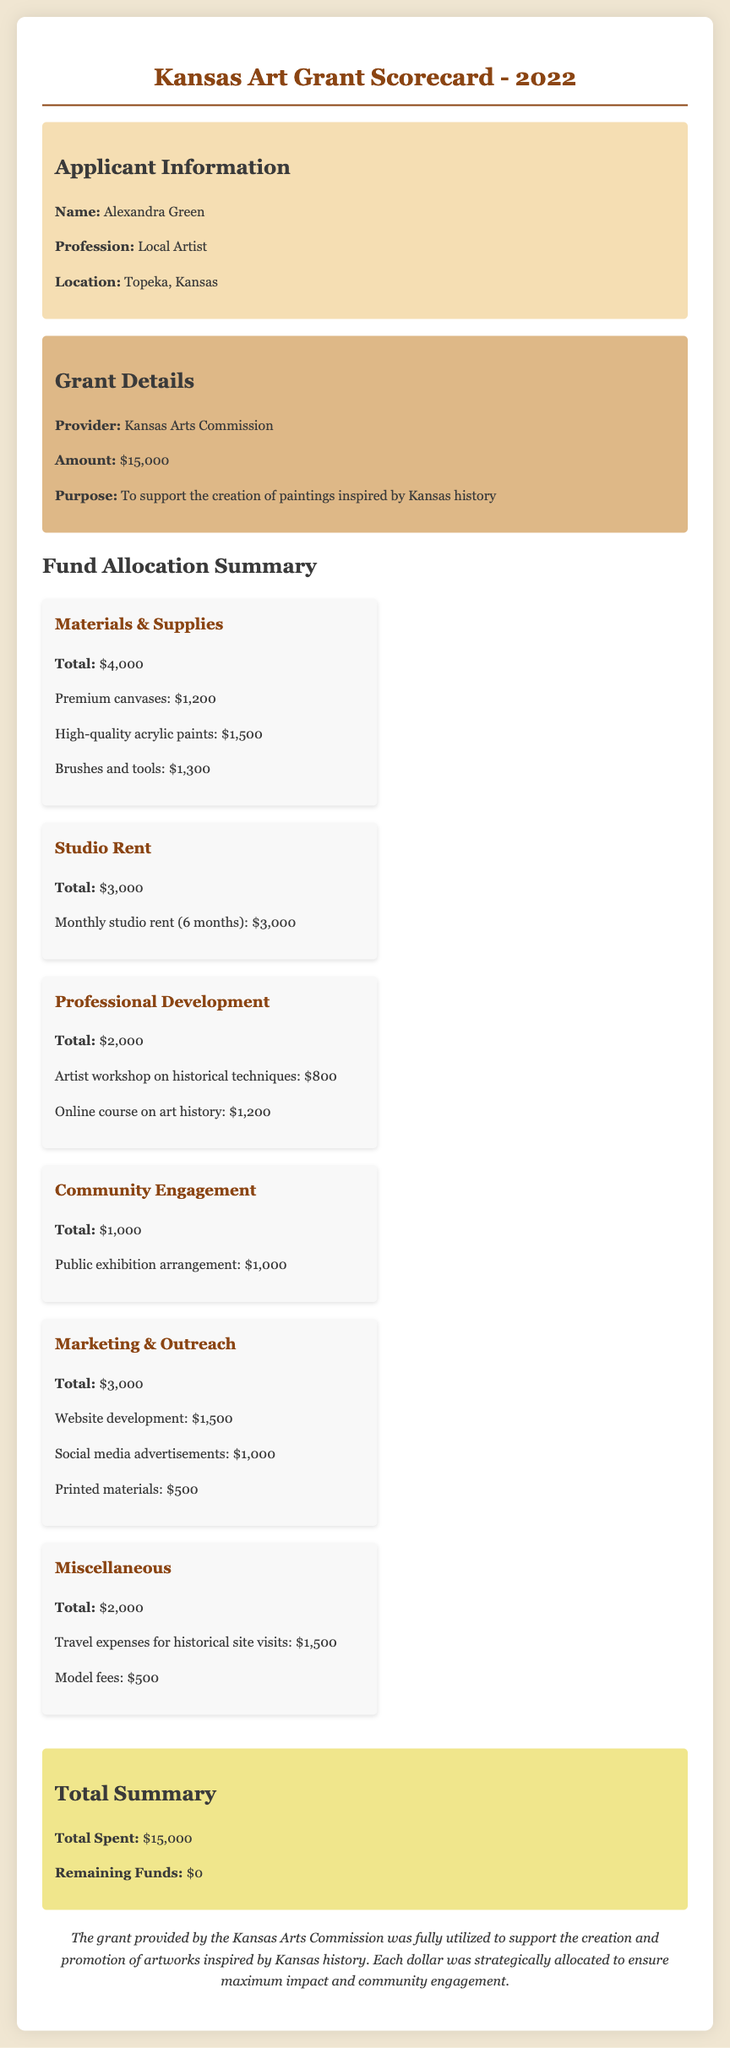what is the name of the applicant? The applicant's name is provided in the document as information related to the applicant.
Answer: Alexandra Green how much was the total grant amount? The total grant amount is stated in the grant details section of the document.
Answer: $15,000 what was the total amount allocated for materials and supplies? The allocation for materials and supplies is listed under the Fund Allocation Summary section.
Answer: $4,000 how much was spent on community engagement? The amount spent on community engagement can be found under the relevant category in the Fund Allocation Summary.
Answer: $1,000 what is the purpose of the grant? The purpose of the grant is mentioned in the grant details section of the document.
Answer: To support the creation of paintings inspired by Kansas history how many months was the studio rent paid for? The studio rent duration is specified in the allocated expenses for studio rent.
Answer: 6 months what was the total spent on professional development? The total amount for professional development expenses is outlined under that category in the document.
Answer: $2,000 how much remained from the total grant amount after allocation? The remaining funds can be found in the total summary section of the document.
Answer: $0 what type of workshop was attended as part of the professional development? The type of workshop is detailed within the expenses of the professional development category.
Answer: Artist workshop on historical techniques 